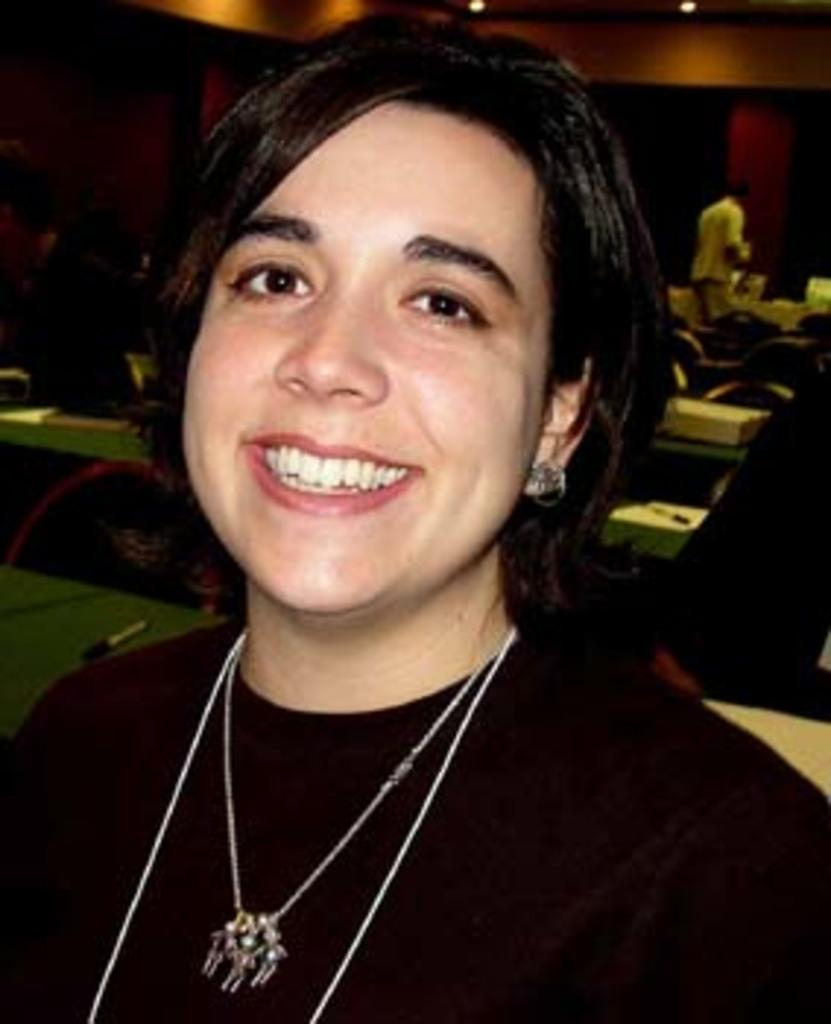Who is the main subject in the image? There is a girl in the image. Where is the girl located in the image? The girl is in the center of the image. What type of brush is the girl using in the image? There is no brush present in the image. What is the girl's limit in the image? The girl's limit is not mentioned or depicted in the image. 